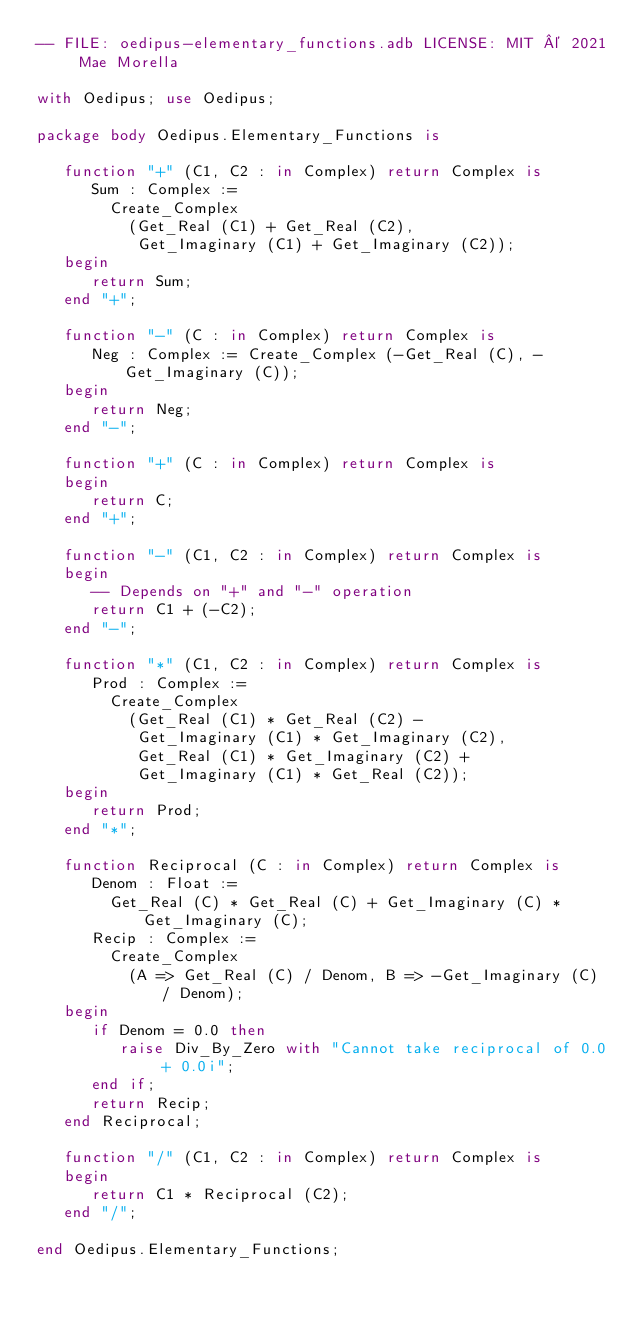Convert code to text. <code><loc_0><loc_0><loc_500><loc_500><_Ada_>-- FILE: oedipus-elementary_functions.adb LICENSE: MIT © 2021 Mae Morella

with Oedipus; use Oedipus;

package body Oedipus.Elementary_Functions is

   function "+" (C1, C2 : in Complex) return Complex is
      Sum : Complex :=
        Create_Complex
          (Get_Real (C1) + Get_Real (C2),
           Get_Imaginary (C1) + Get_Imaginary (C2));
   begin
      return Sum;
   end "+";

   function "-" (C : in Complex) return Complex is
      Neg : Complex := Create_Complex (-Get_Real (C), -Get_Imaginary (C));
   begin
      return Neg;
   end "-";

   function "+" (C : in Complex) return Complex is
   begin
      return C;
   end "+";

   function "-" (C1, C2 : in Complex) return Complex is
   begin
      -- Depends on "+" and "-" operation
      return C1 + (-C2);
   end "-";

   function "*" (C1, C2 : in Complex) return Complex is
      Prod : Complex :=
        Create_Complex
          (Get_Real (C1) * Get_Real (C2) -
           Get_Imaginary (C1) * Get_Imaginary (C2),
           Get_Real (C1) * Get_Imaginary (C2) +
           Get_Imaginary (C1) * Get_Real (C2));
   begin
      return Prod;
   end "*";

   function Reciprocal (C : in Complex) return Complex is
      Denom : Float :=
        Get_Real (C) * Get_Real (C) + Get_Imaginary (C) * Get_Imaginary (C);
      Recip : Complex :=
        Create_Complex
          (A => Get_Real (C) / Denom, B => -Get_Imaginary (C) / Denom);
   begin
      if Denom = 0.0 then
         raise Div_By_Zero with "Cannot take reciprocal of 0.0 + 0.0i";
      end if;
      return Recip;
   end Reciprocal;

   function "/" (C1, C2 : in Complex) return Complex is
   begin
      return C1 * Reciprocal (C2);
   end "/";

end Oedipus.Elementary_Functions;
</code> 